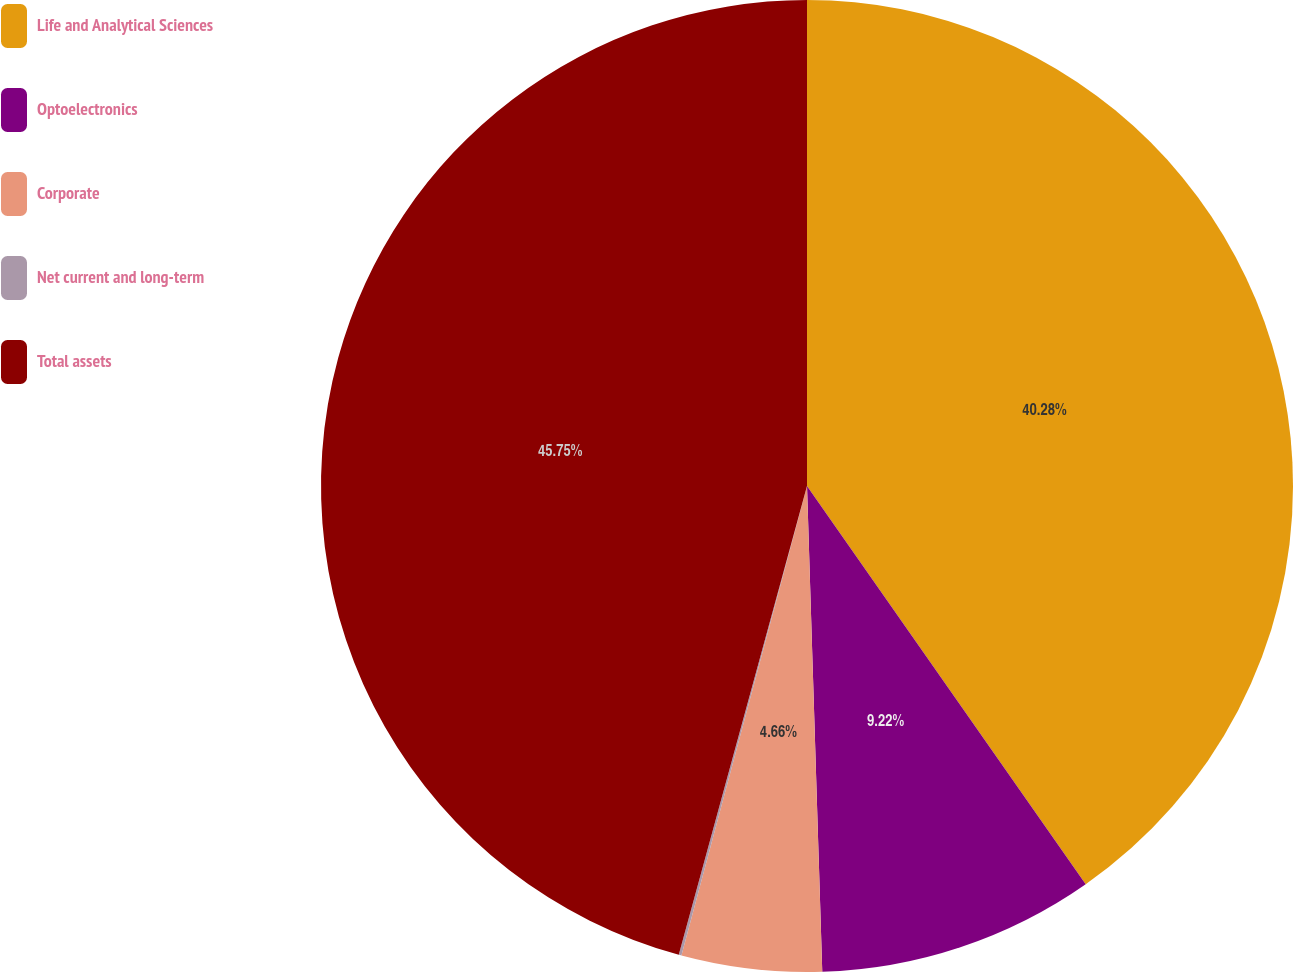Convert chart. <chart><loc_0><loc_0><loc_500><loc_500><pie_chart><fcel>Life and Analytical Sciences<fcel>Optoelectronics<fcel>Corporate<fcel>Net current and long-term<fcel>Total assets<nl><fcel>40.28%<fcel>9.22%<fcel>4.66%<fcel>0.09%<fcel>45.75%<nl></chart> 